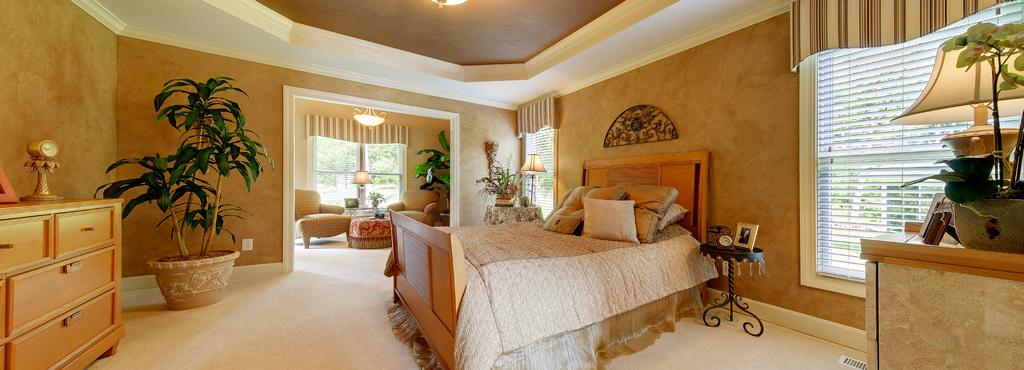What type of furniture is present in the room? There is a bed, a small stool, a lamp, and a sofa in the room. What can be found on the bed? The bed has a set of pillows. What type of storage is available in the room? There are cupboards on the opposite side of the room. What decorative or living element is present in the room? There is a house plant in the room. What is the purpose of the lamp in the room? The lamp provides light in the room. What type of plant is used to stop the car in the image? There is no car or plant used for braking in the image; it features a room with a bed, stool, lamp, cupboards, and a house plant. 